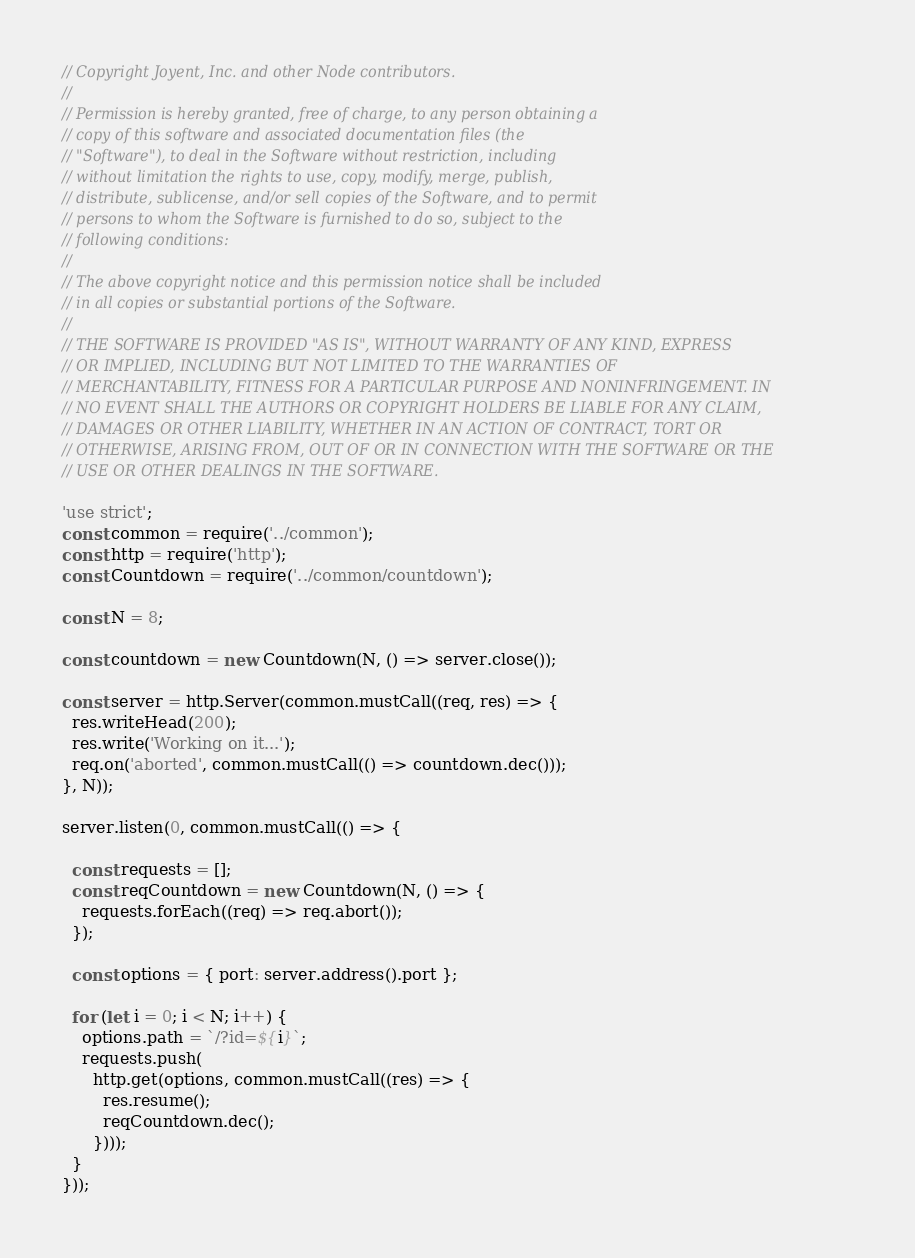Convert code to text. <code><loc_0><loc_0><loc_500><loc_500><_JavaScript_>// Copyright Joyent, Inc. and other Node contributors.
//
// Permission is hereby granted, free of charge, to any person obtaining a
// copy of this software and associated documentation files (the
// "Software"), to deal in the Software without restriction, including
// without limitation the rights to use, copy, modify, merge, publish,
// distribute, sublicense, and/or sell copies of the Software, and to permit
// persons to whom the Software is furnished to do so, subject to the
// following conditions:
//
// The above copyright notice and this permission notice shall be included
// in all copies or substantial portions of the Software.
//
// THE SOFTWARE IS PROVIDED "AS IS", WITHOUT WARRANTY OF ANY KIND, EXPRESS
// OR IMPLIED, INCLUDING BUT NOT LIMITED TO THE WARRANTIES OF
// MERCHANTABILITY, FITNESS FOR A PARTICULAR PURPOSE AND NONINFRINGEMENT. IN
// NO EVENT SHALL THE AUTHORS OR COPYRIGHT HOLDERS BE LIABLE FOR ANY CLAIM,
// DAMAGES OR OTHER LIABILITY, WHETHER IN AN ACTION OF CONTRACT, TORT OR
// OTHERWISE, ARISING FROM, OUT OF OR IN CONNECTION WITH THE SOFTWARE OR THE
// USE OR OTHER DEALINGS IN THE SOFTWARE.

'use strict';
const common = require('../common');
const http = require('http');
const Countdown = require('../common/countdown');

const N = 8;

const countdown = new Countdown(N, () => server.close());

const server = http.Server(common.mustCall((req, res) => {
  res.writeHead(200);
  res.write('Working on it...');
  req.on('aborted', common.mustCall(() => countdown.dec()));
}, N));

server.listen(0, common.mustCall(() => {

  const requests = [];
  const reqCountdown = new Countdown(N, () => {
    requests.forEach((req) => req.abort());
  });

  const options = { port: server.address().port };

  for (let i = 0; i < N; i++) {
    options.path = `/?id=${i}`;
    requests.push(
      http.get(options, common.mustCall((res) => {
        res.resume();
        reqCountdown.dec();
      })));
  }
}));
</code> 